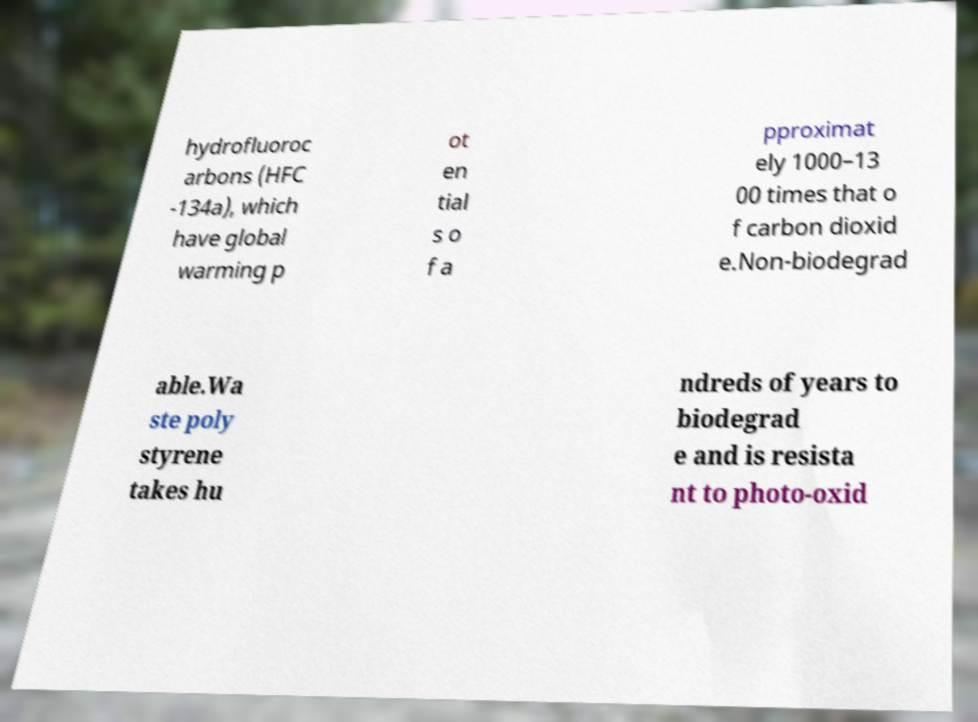Could you assist in decoding the text presented in this image and type it out clearly? hydrofluoroc arbons (HFC -134a), which have global warming p ot en tial s o f a pproximat ely 1000–13 00 times that o f carbon dioxid e.Non-biodegrad able.Wa ste poly styrene takes hu ndreds of years to biodegrad e and is resista nt to photo-oxid 